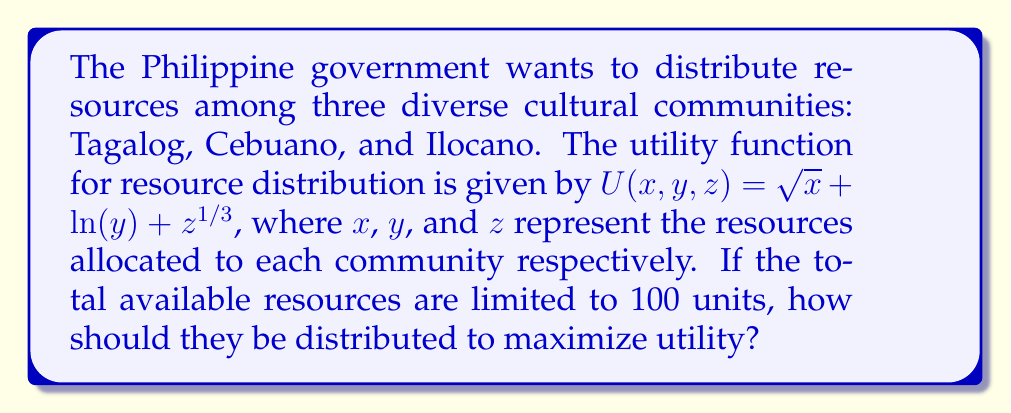Provide a solution to this math problem. To solve this optimization problem, we'll use the method of Lagrange multipliers:

1) First, set up the constraint equation:
   $g(x, y, z) = x + y + z - 100 = 0$

2) Form the Lagrangian function:
   $L(x, y, z, \lambda) = \sqrt{x} + \ln(y) + z^{1/3} - \lambda(x + y + z - 100)$

3) Take partial derivatives and set them equal to zero:
   $\frac{\partial L}{\partial x} = \frac{1}{2\sqrt{x}} - \lambda = 0$
   $\frac{\partial L}{\partial y} = \frac{1}{y} - \lambda = 0$
   $\frac{\partial L}{\partial z} = \frac{1}{3z^{2/3}} - \lambda = 0$
   $\frac{\partial L}{\partial \lambda} = x + y + z - 100 = 0$

4) From these equations, we can deduce:
   $\frac{1}{2\sqrt{x}} = \frac{1}{y} = \frac{1}{3z^{2/3}} = \lambda$

5) This gives us the relationships:
   $y = 2\sqrt{x}$ and $z = \frac{1}{27x}$

6) Substitute these into the constraint equation:
   $x + 2\sqrt{x} + \frac{1}{27x} = 100$

7) This equation can be solved numerically to get $x \approx 36.0$

8) Using this value, we can calculate $y$ and $z$:
   $y \approx 12.0$ and $z \approx 52.0$

Therefore, the optimal distribution is approximately 36 units to the Tagalog community, 12 units to the Cebuano community, and 52 units to the Ilocano community.
Answer: (36, 12, 52) 